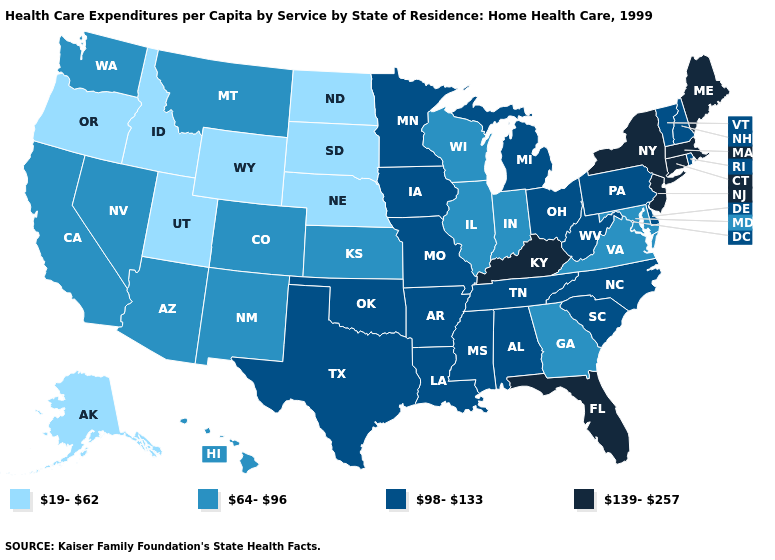Name the states that have a value in the range 64-96?
Keep it brief. Arizona, California, Colorado, Georgia, Hawaii, Illinois, Indiana, Kansas, Maryland, Montana, Nevada, New Mexico, Virginia, Washington, Wisconsin. Which states have the lowest value in the USA?
Quick response, please. Alaska, Idaho, Nebraska, North Dakota, Oregon, South Dakota, Utah, Wyoming. What is the value of Arizona?
Give a very brief answer. 64-96. What is the lowest value in states that border Wisconsin?
Write a very short answer. 64-96. Does South Carolina have the lowest value in the USA?
Keep it brief. No. Does Oregon have a lower value than Mississippi?
Give a very brief answer. Yes. What is the value of Arizona?
Be succinct. 64-96. Does Florida have the highest value in the South?
Give a very brief answer. Yes. What is the lowest value in states that border Colorado?
Be succinct. 19-62. Which states have the highest value in the USA?
Be succinct. Connecticut, Florida, Kentucky, Maine, Massachusetts, New Jersey, New York. Does Montana have the same value as West Virginia?
Be succinct. No. What is the value of New Mexico?
Keep it brief. 64-96. What is the value of Wisconsin?
Keep it brief. 64-96. Which states hav the highest value in the MidWest?
Concise answer only. Iowa, Michigan, Minnesota, Missouri, Ohio. Which states have the lowest value in the MidWest?
Answer briefly. Nebraska, North Dakota, South Dakota. 